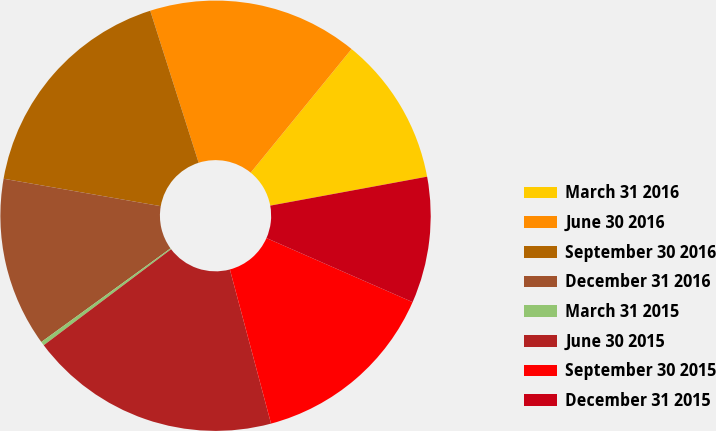Convert chart to OTSL. <chart><loc_0><loc_0><loc_500><loc_500><pie_chart><fcel>March 31 2016<fcel>June 30 2016<fcel>September 30 2016<fcel>December 31 2016<fcel>March 31 2015<fcel>June 30 2015<fcel>September 30 2015<fcel>December 31 2015<nl><fcel>11.2%<fcel>15.8%<fcel>17.34%<fcel>12.73%<fcel>0.3%<fcel>18.87%<fcel>14.27%<fcel>9.48%<nl></chart> 